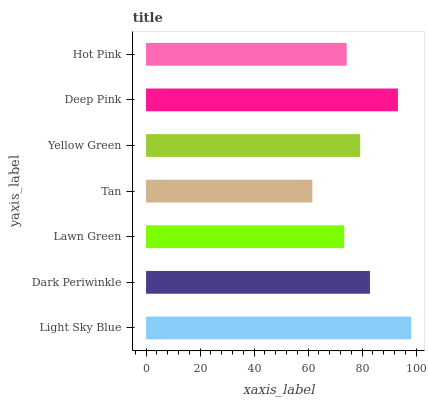Is Tan the minimum?
Answer yes or no. Yes. Is Light Sky Blue the maximum?
Answer yes or no. Yes. Is Dark Periwinkle the minimum?
Answer yes or no. No. Is Dark Periwinkle the maximum?
Answer yes or no. No. Is Light Sky Blue greater than Dark Periwinkle?
Answer yes or no. Yes. Is Dark Periwinkle less than Light Sky Blue?
Answer yes or no. Yes. Is Dark Periwinkle greater than Light Sky Blue?
Answer yes or no. No. Is Light Sky Blue less than Dark Periwinkle?
Answer yes or no. No. Is Yellow Green the high median?
Answer yes or no. Yes. Is Yellow Green the low median?
Answer yes or no. Yes. Is Hot Pink the high median?
Answer yes or no. No. Is Dark Periwinkle the low median?
Answer yes or no. No. 